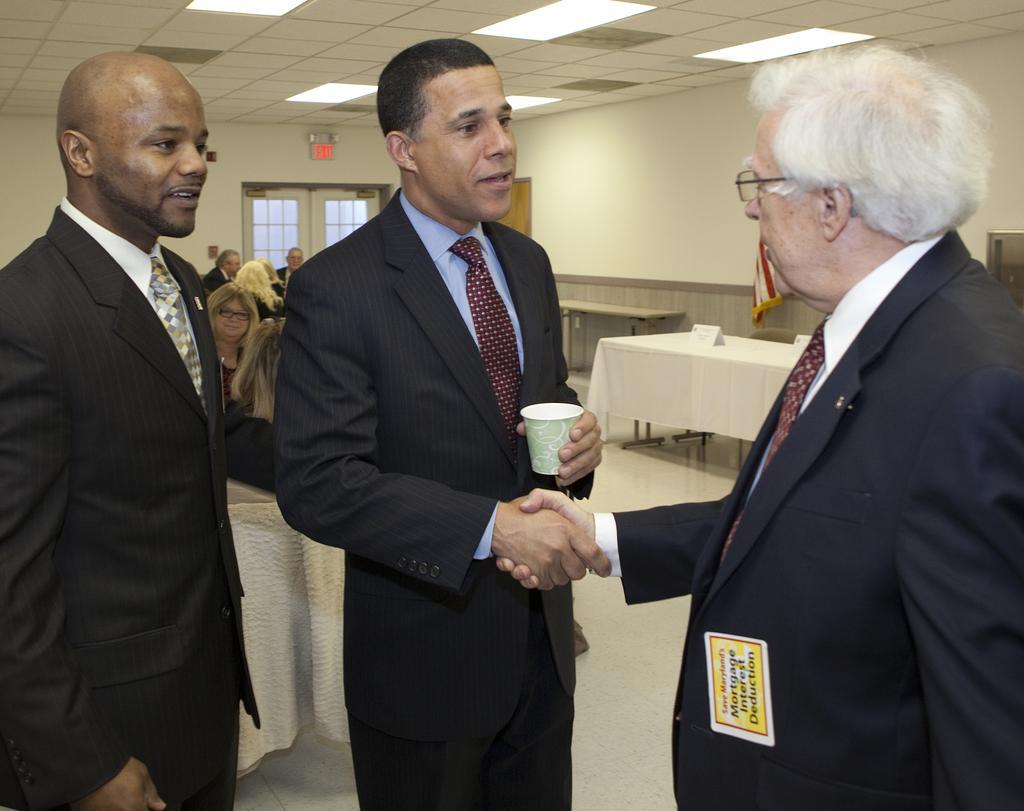Could you give a brief overview of what you see in this image? In this image I can see three people standing two people on the left hand side are facing towards the right one person is facing towards the left. Two people standing on the right hand side are shaking their hands one person among them is holding a glass in his hand. I can see other people behind them. I can see a window, doors, tables and false ceiling with some lights.  